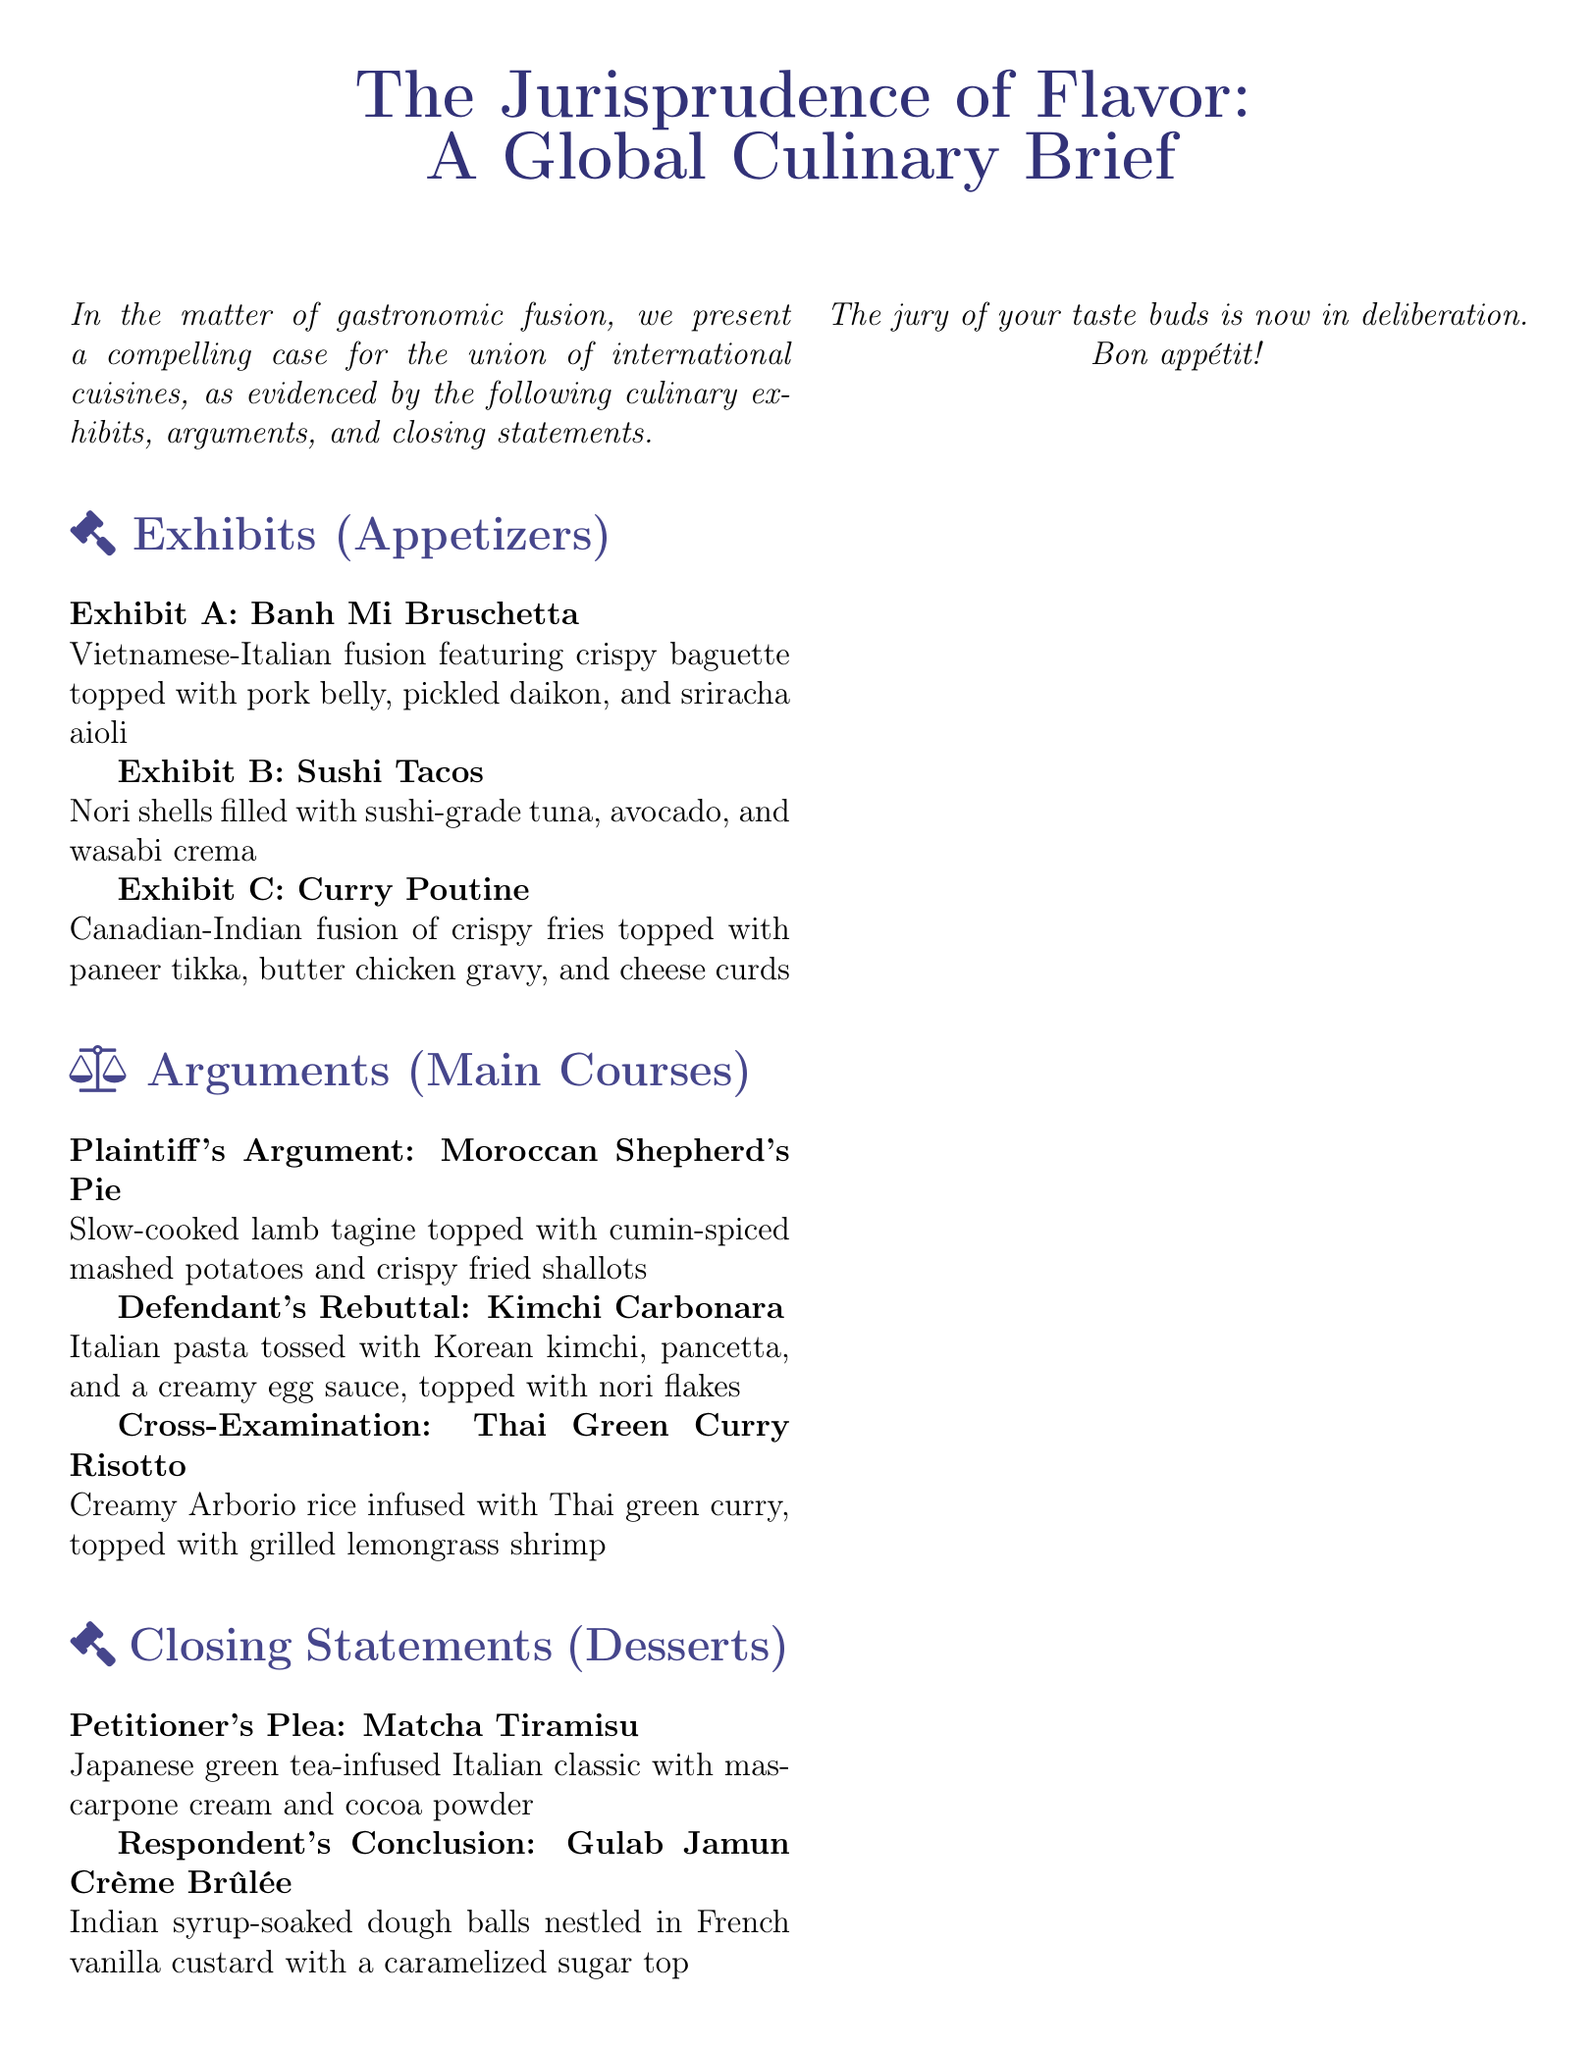What is the title of the menu? The title is presented prominently at the top of the document in a larger font size.
Answer: The Jurisprudence of Flavor: A Global Culinary Brief How many appetizers are listed? The number of appetizers is provided in the "Exhibits" section of the document.
Answer: Three What is the first appetizer? The first appetizer can be found in the list under the "Exhibits" section.
Answer: Banh Mi Bruschetta What type of cuisine is the Moroccan Shepherd's Pie associated with? The cuisine type can be inferred from the description provided under the "Arguments" section.
Answer: Moroccan What ingredient is topped on Kimchi Carbonara? The key ingredient is specified in the description of the Main Course under the "Defendant's Rebuttal."
Answer: Nori flakes What dessert includes matcha? The dessert title specifically highlights the inclusion of matcha in its name.
Answer: Matcha Tiramisu Which country's flavors are combined in the Curry Poutine? The fusion of cuisines is indicated in the description of the appetizer.
Answer: Canadian-Indian What is the unique feature of the Gulab Jamun Crème Brûlée? The unique feature is described in the closing statement under the "Respondent's Conclusion."
Answer: Caramelized sugar top How is the Thai Green Curry Risotto topped? The topping is specifically mentioned in the description of the dish in the "Cross-Examination" section.
Answer: Grilled lemongrass shrimp 